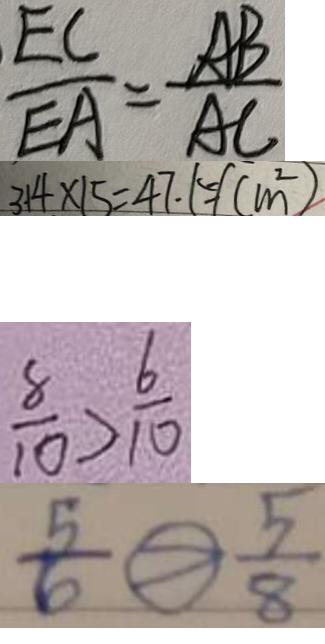Convert formula to latex. <formula><loc_0><loc_0><loc_500><loc_500>\frac { E C } { E A } = \frac { A B } { A C } 
 3 1 4 \times 1 5 = 4 7 . 1 5 ( c m ^ { 2 } ) 
 \frac { 8 } { 1 0 } > \frac { 6 } { 1 0 } 
 \frac { 5 } { 6 } \textcircled { > } \frac { 5 } { 8 }</formula> 